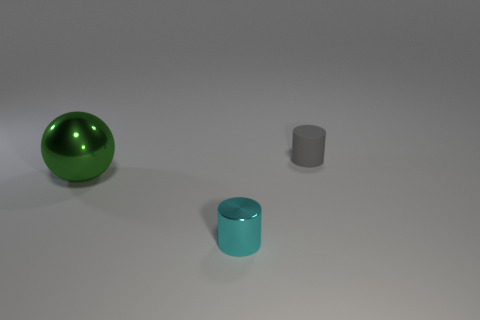Is there any other thing that is the same color as the big ball?
Your answer should be very brief. No. Is the number of rubber cylinders that are behind the green shiny sphere greater than the number of cyan objects behind the cyan cylinder?
Offer a very short reply. Yes. The green thing has what size?
Give a very brief answer. Large. There is a tiny cyan thing that is the same material as the large green object; what is its shape?
Your answer should be very brief. Cylinder. There is a small thing on the left side of the gray object; is it the same shape as the big metallic object?
Provide a short and direct response. No. What number of objects are either things or rubber objects?
Provide a short and direct response. 3. What material is the thing that is both behind the small cyan metallic cylinder and in front of the tiny gray matte cylinder?
Your response must be concise. Metal. Do the matte cylinder and the cyan metal cylinder have the same size?
Keep it short and to the point. Yes. How big is the cylinder in front of the object behind the big green object?
Provide a succinct answer. Small. What number of things are right of the cyan metal object and to the left of the tiny cyan thing?
Offer a terse response. 0. 